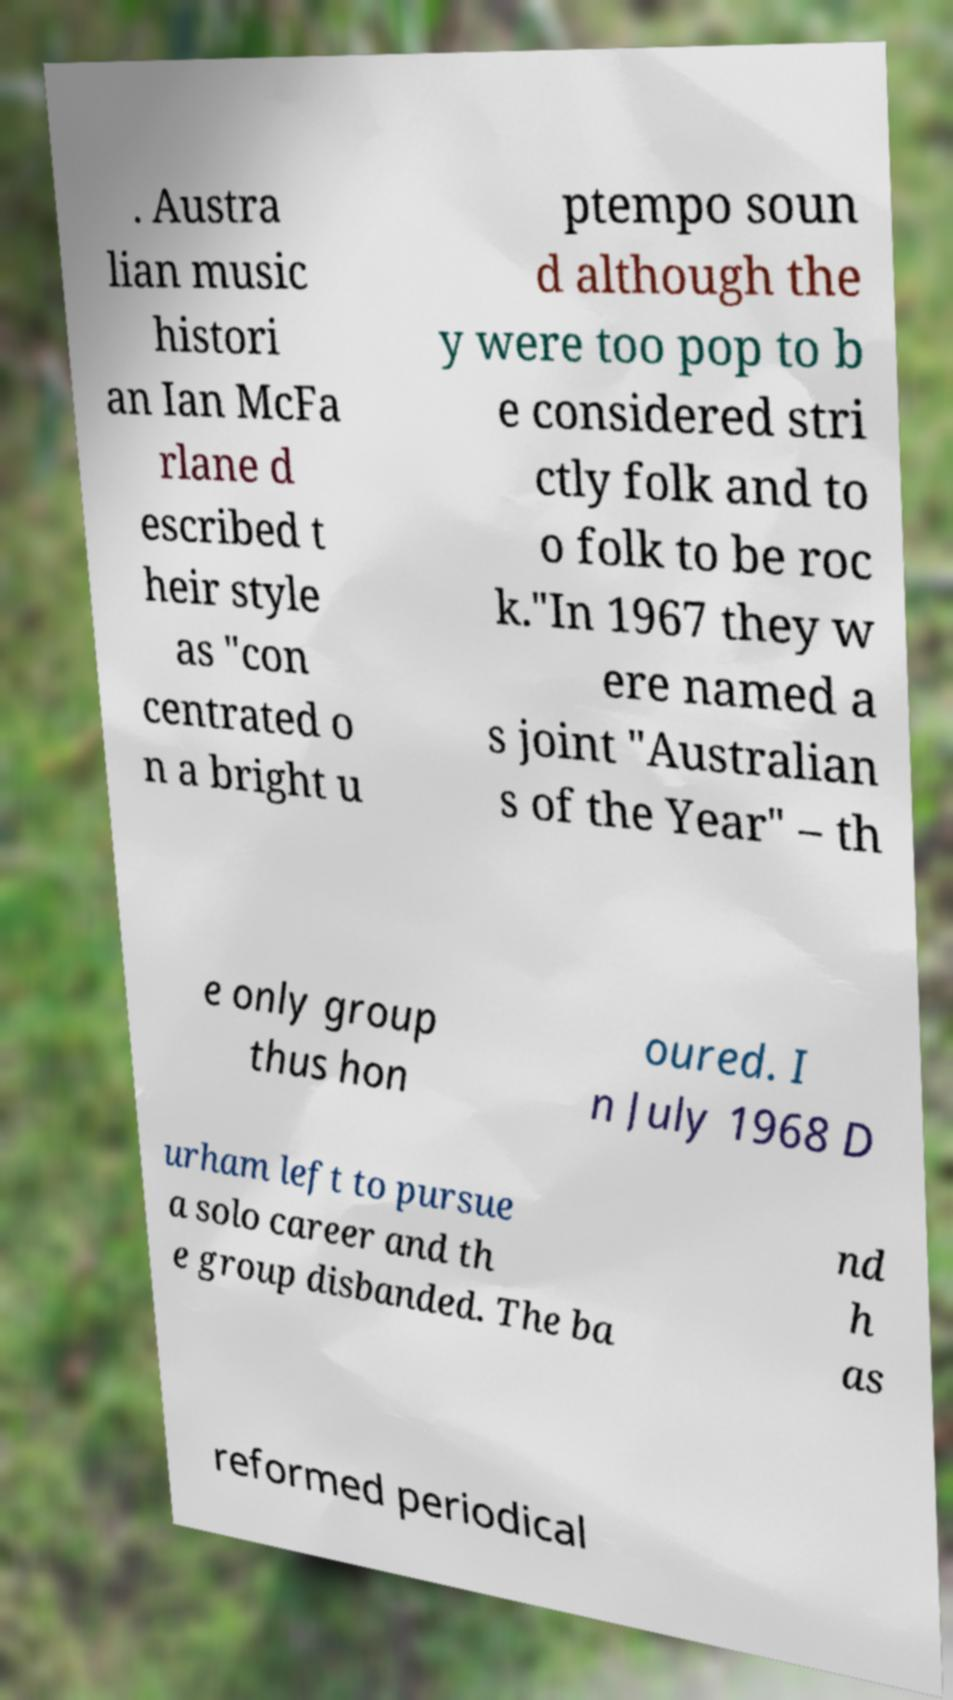Could you extract and type out the text from this image? . Austra lian music histori an Ian McFa rlane d escribed t heir style as "con centrated o n a bright u ptempo soun d although the y were too pop to b e considered stri ctly folk and to o folk to be roc k."In 1967 they w ere named a s joint "Australian s of the Year" – th e only group thus hon oured. I n July 1968 D urham left to pursue a solo career and th e group disbanded. The ba nd h as reformed periodical 